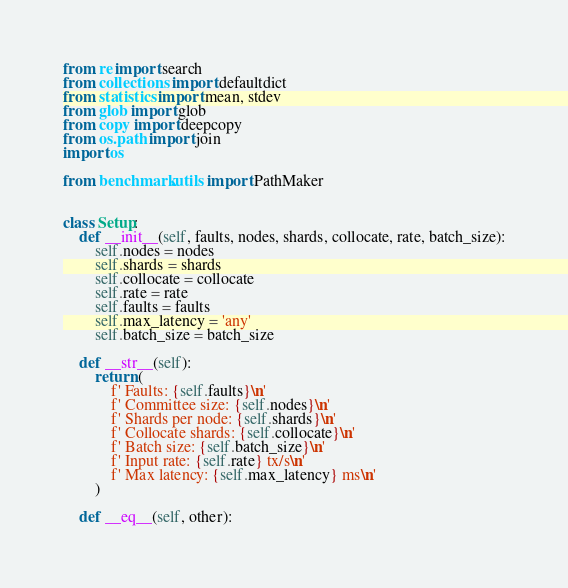<code> <loc_0><loc_0><loc_500><loc_500><_Python_>from re import search
from collections import defaultdict
from statistics import mean, stdev
from glob import glob
from copy import deepcopy
from os.path import join
import os

from benchmark.utils import PathMaker


class Setup:
    def __init__(self, faults, nodes, shards, collocate, rate, batch_size):
        self.nodes = nodes
        self.shards = shards
        self.collocate = collocate
        self.rate = rate
        self.faults = faults
        self.max_latency = 'any'
        self.batch_size = batch_size

    def __str__(self):
        return (
            f' Faults: {self.faults}\n'
            f' Committee size: {self.nodes}\n'
            f' Shards per node: {self.shards}\n'
            f' Collocate shards: {self.collocate}\n'
            f' Batch size: {self.batch_size}\n'
            f' Input rate: {self.rate} tx/s\n'
            f' Max latency: {self.max_latency} ms\n'
        )

    def __eq__(self, other):</code> 